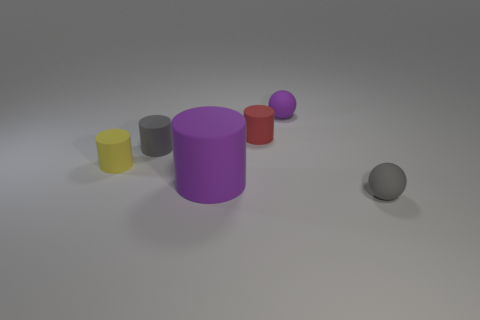Are there any other things that have the same size as the yellow thing?
Your answer should be very brief. Yes. Is the number of small purple matte things that are in front of the small gray matte cylinder greater than the number of purple cylinders that are to the left of the yellow matte cylinder?
Ensure brevity in your answer.  No. There is a object that is on the left side of the small gray object left of the purple rubber thing behind the tiny yellow object; what is its color?
Offer a very short reply. Yellow. Do the small cylinder behind the gray matte cylinder and the big matte object have the same color?
Offer a very short reply. No. What number of other things are the same color as the big cylinder?
Your answer should be very brief. 1. How many objects are either small cyan metal cylinders or yellow cylinders?
Your answer should be very brief. 1. What number of things are either tiny rubber balls or yellow things that are behind the big cylinder?
Your response must be concise. 3. Is the red object made of the same material as the gray cylinder?
Offer a very short reply. Yes. How many other things are there of the same material as the gray cylinder?
Keep it short and to the point. 5. Are there more things than tiny matte things?
Make the answer very short. Yes. 